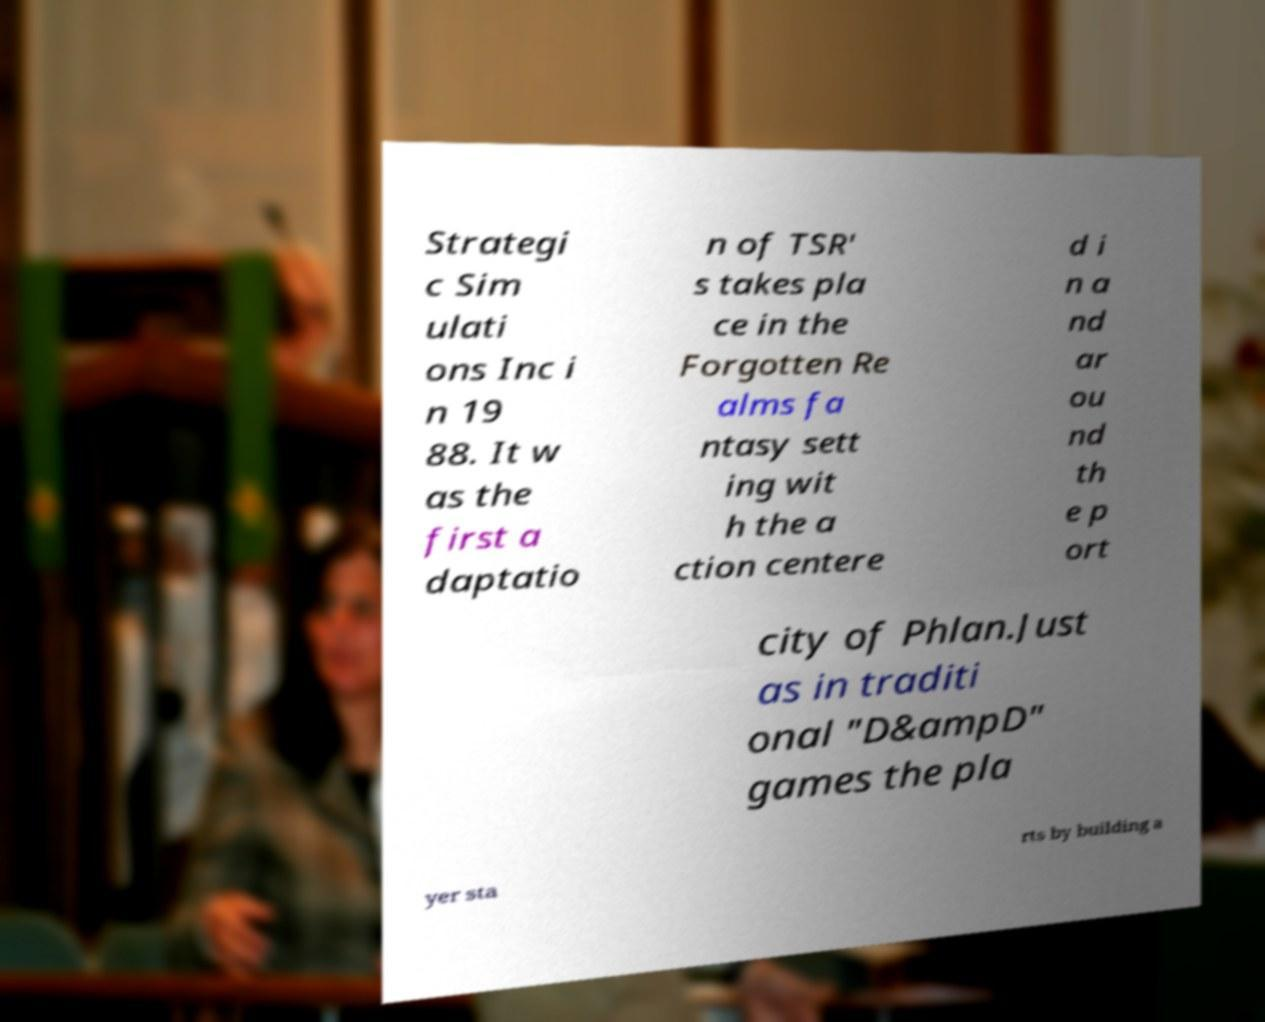I need the written content from this picture converted into text. Can you do that? Strategi c Sim ulati ons Inc i n 19 88. It w as the first a daptatio n of TSR' s takes pla ce in the Forgotten Re alms fa ntasy sett ing wit h the a ction centere d i n a nd ar ou nd th e p ort city of Phlan.Just as in traditi onal "D&ampD" games the pla yer sta rts by building a 